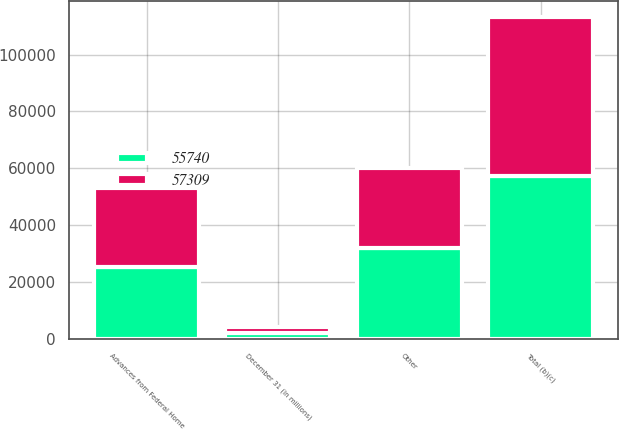Convert chart. <chart><loc_0><loc_0><loc_500><loc_500><stacked_bar_chart><ecel><fcel>December 31 (in millions)<fcel>Advances from Federal Home<fcel>Other<fcel>Total (b)(c)<nl><fcel>55740<fcel>2010<fcel>25234<fcel>32075<fcel>57309<nl><fcel>57309<fcel>2009<fcel>27847<fcel>27893<fcel>55740<nl></chart> 